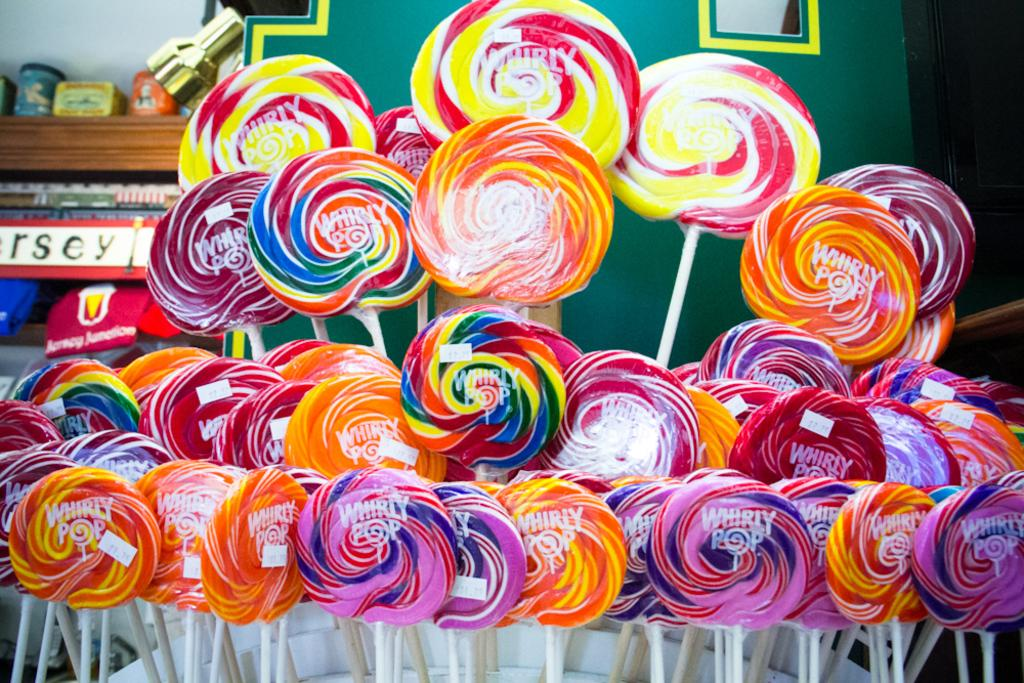What type of food can be seen in the image? There are candies in the image. What structure is present in the image? There is a shelf in the image. What is placed on the shelf? There are items placed on the shelf. What type of cheese is placed on the shelf in the image? There is no cheese present in the image; it only features candies and a shelf. 